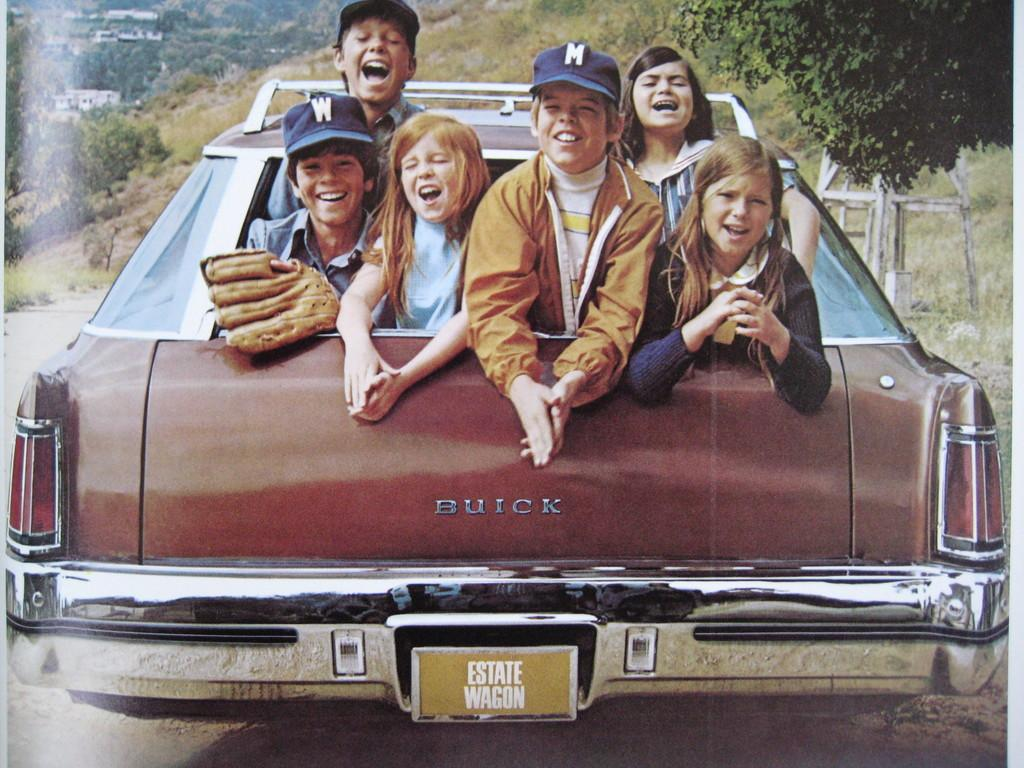What is the main subject of the image? The main subject of the image is a group of children. Where are the children located in the image? The children are sitting in a car. What is the emotional state of the children in the image? The children are smiling in the image. What is the children's interest in the image? The provided facts do not mention any specific interests of the children, so we cannot determine their interests from the image. 